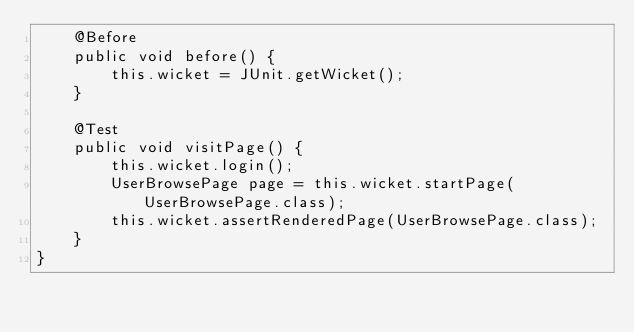Convert code to text. <code><loc_0><loc_0><loc_500><loc_500><_Java_>    @Before
    public void before() {
        this.wicket = JUnit.getWicket();
    }

    @Test
    public void visitPage() {
        this.wicket.login();
        UserBrowsePage page = this.wicket.startPage(UserBrowsePage.class);
        this.wicket.assertRenderedPage(UserBrowsePage.class);
    }
}
</code> 